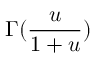<formula> <loc_0><loc_0><loc_500><loc_500>\Gamma ( \frac { u } { 1 + u } )</formula> 